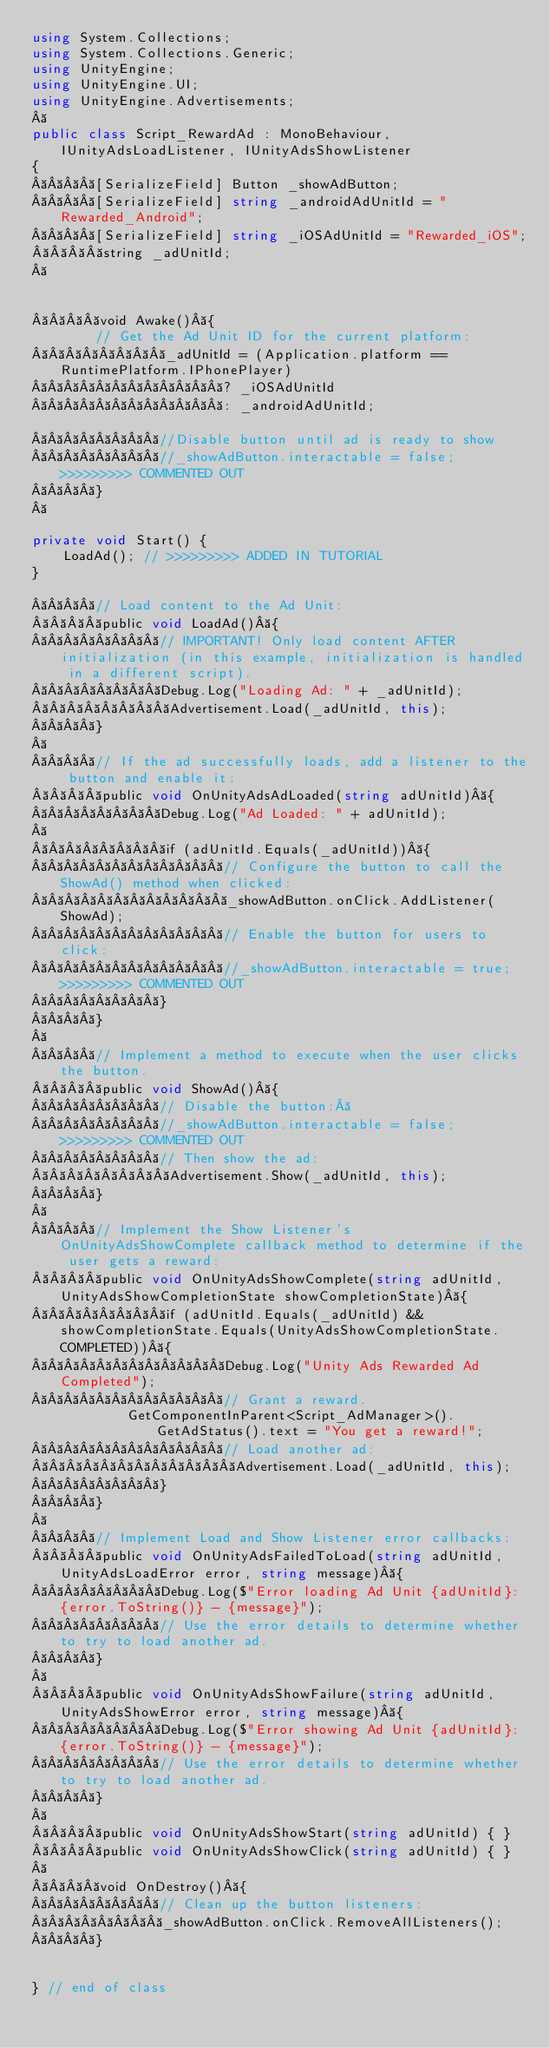Convert code to text. <code><loc_0><loc_0><loc_500><loc_500><_C#_>using System.Collections;
using System.Collections.Generic;
using UnityEngine;
using UnityEngine.UI;
using UnityEngine.Advertisements;
 
public class Script_RewardAd : MonoBehaviour, IUnityAdsLoadListener, IUnityAdsShowListener
{
    [SerializeField] Button _showAdButton;
    [SerializeField] string _androidAdUnitId = "Rewarded_Android";
    [SerializeField] string _iOSAdUnitId = "Rewarded_iOS";
    string _adUnitId;
 


    void Awake() {
        // Get the Ad Unit ID for the current platform:
        _adUnitId = (Application.platform == RuntimePlatform.IPhonePlayer)
            ? _iOSAdUnitId
            : _androidAdUnitId;

        //Disable button until ad is ready to show
        //_showAdButton.interactable = false; >>>>>>>>> COMMENTED OUT
    }
 

private void Start() {
    LoadAd(); // >>>>>>>>> ADDED IN TUTORIAL
}

    // Load content to the Ad Unit:
    public void LoadAd() {
        // IMPORTANT! Only load content AFTER initialization (in this example, initialization is handled in a different script).
        Debug.Log("Loading Ad: " + _adUnitId);
        Advertisement.Load(_adUnitId, this);
    }
 
    // If the ad successfully loads, add a listener to the button and enable it:
    public void OnUnityAdsAdLoaded(string adUnitId) {
        Debug.Log("Ad Loaded: " + adUnitId);
 
        if (adUnitId.Equals(_adUnitId)) {
            // Configure the button to call the ShowAd() method when clicked:
            _showAdButton.onClick.AddListener(ShowAd);
            // Enable the button for users to click:
            //_showAdButton.interactable = true; >>>>>>>>> COMMENTED OUT
        }
    }
 
    // Implement a method to execute when the user clicks the button.
    public void ShowAd() {
        // Disable the button: 
        //_showAdButton.interactable = false; >>>>>>>>> COMMENTED OUT
        // Then show the ad:
        Advertisement.Show(_adUnitId, this);
    }
 
    // Implement the Show Listener's OnUnityAdsShowComplete callback method to determine if the user gets a reward:
    public void OnUnityAdsShowComplete(string adUnitId, UnityAdsShowCompletionState showCompletionState) {
        if (adUnitId.Equals(_adUnitId) && showCompletionState.Equals(UnityAdsShowCompletionState.COMPLETED)) {
            Debug.Log("Unity Ads Rewarded Ad Completed");
            // Grant a reward.
            GetComponentInParent<Script_AdManager>().GetAdStatus().text = "You get a reward!";
            // Load another ad:
            Advertisement.Load(_adUnitId, this);
        }
    }
 
    // Implement Load and Show Listener error callbacks:
    public void OnUnityAdsFailedToLoad(string adUnitId, UnityAdsLoadError error, string message) {
        Debug.Log($"Error loading Ad Unit {adUnitId}: {error.ToString()} - {message}");
        // Use the error details to determine whether to try to load another ad.
    }
 
    public void OnUnityAdsShowFailure(string adUnitId, UnityAdsShowError error, string message) {
        Debug.Log($"Error showing Ad Unit {adUnitId}: {error.ToString()} - {message}");
        // Use the error details to determine whether to try to load another ad.
    }
 
    public void OnUnityAdsShowStart(string adUnitId) { }
    public void OnUnityAdsShowClick(string adUnitId) { }
 
    void OnDestroy() {
        // Clean up the button listeners:
        _showAdButton.onClick.RemoveAllListeners();
    }


} // end of class
</code> 